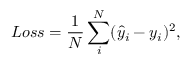Convert formula to latex. <formula><loc_0><loc_0><loc_500><loc_500>L o s s = \frac { 1 } { N } \sum _ { i } ^ { N } ( \hat { y } _ { i } - y _ { i } ) ^ { 2 } ,</formula> 